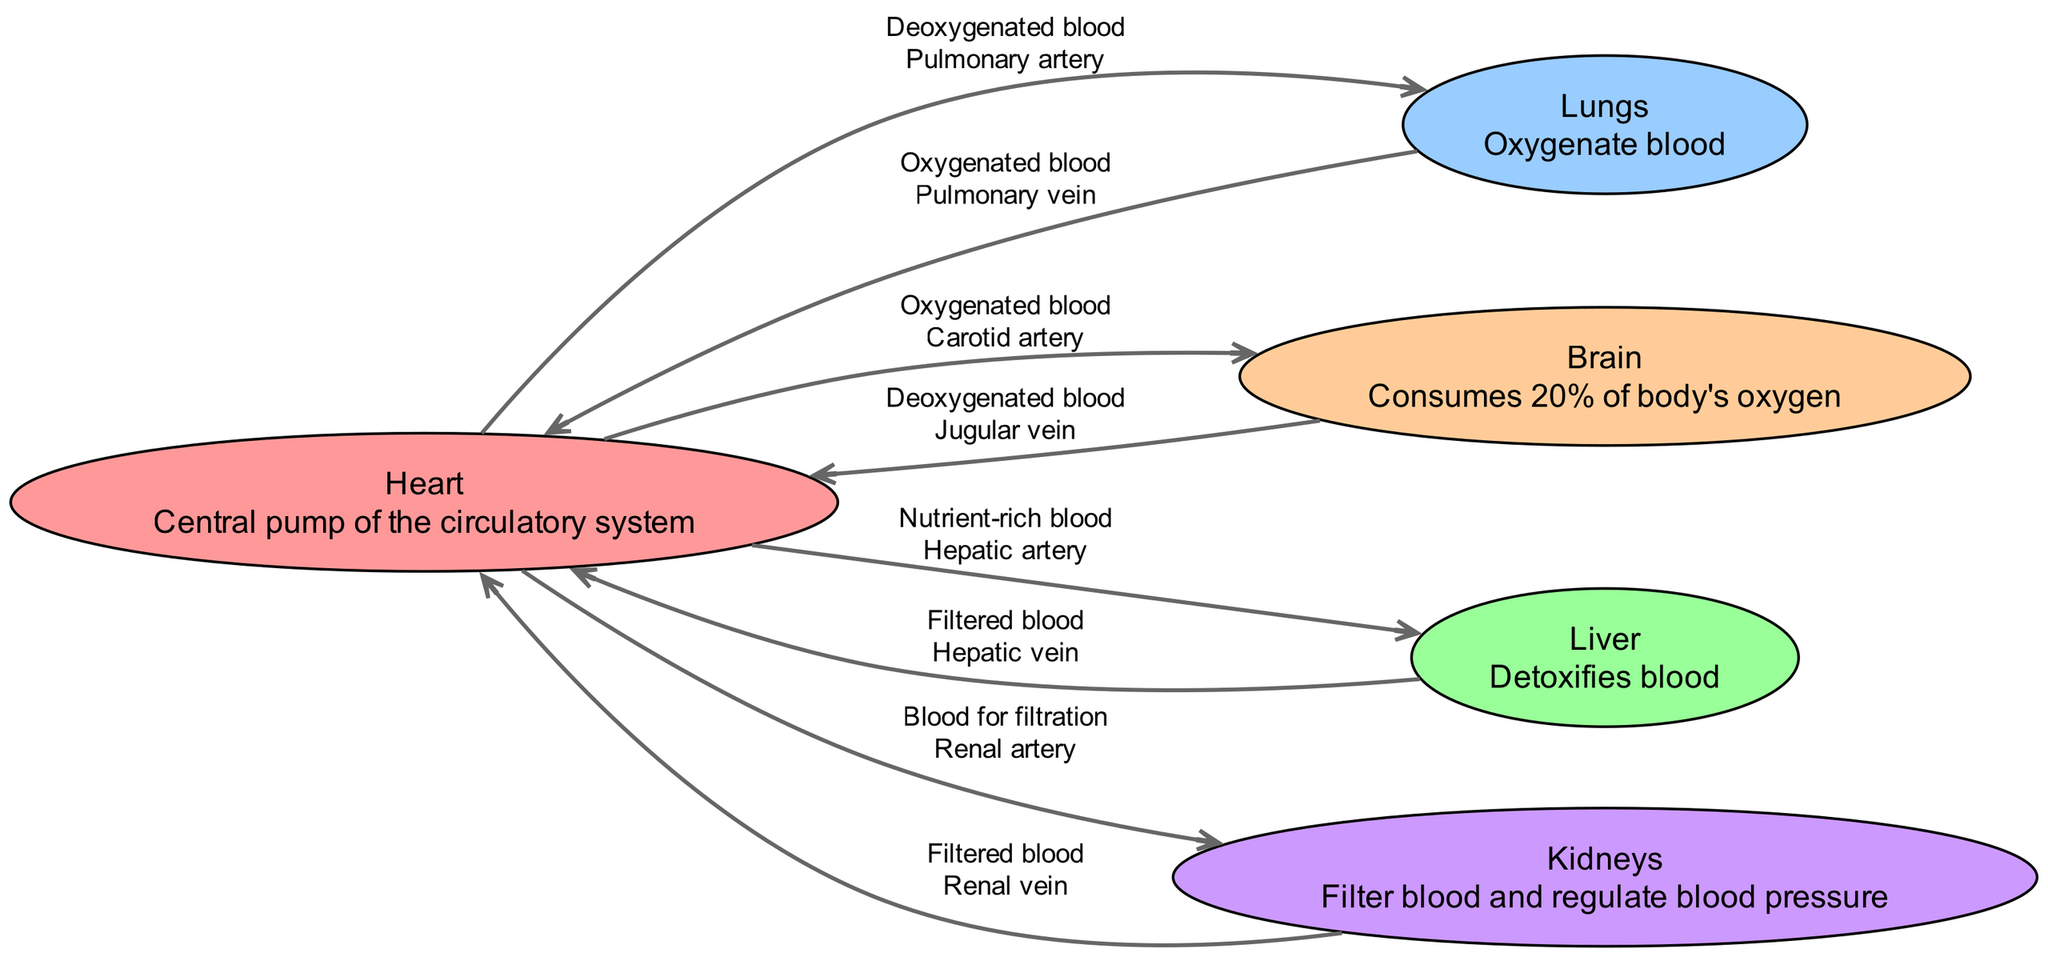What is the central pump of the circulatory system? The diagram identifies the "Heart" as the central pump, described in the node label. This is a basic descriptive question focusing on identifying a specific component of the circulatory system.
Answer: Heart How many nodes are in the diagram? By counting the entries in the "nodes" section of the data, we find there are 5 different organs indicated, all represented as nodes. This is a straightforward descriptive inquiry.
Answer: 5 What type of blood does the pulmonary artery carry? The edge connecting the heart to the lungs is labeled "Deoxygenated blood." This succinctly indicates the type of blood transported through this pathway.
Answer: Deoxygenated blood Which artery supplies blood to the brain? The diagram shows an edge leading from the heart to the brain labeled "Oxygenated blood," associated with the "Carotid artery." This connection illustrates the route oxygenated blood takes to the brain.
Answer: Carotid artery What organ receives filtered blood from the kidneys? Tracing the diagram from the kidneys to the heart shows the renal vein connecting them, demonstrating that the heart receives filtered blood after kidney processing. This question requires linking two processes within the diagram.
Answer: Heart What percentage of the body’s oxygen does the brain consume? The node description for the brain specifies that it consumes "20% of body's oxygen." This is a numerical inquiry based on the node's description.
Answer: 20% What is the role of the liver in the circulatory system? The liver is described in its node as having the function to "Detoxifies blood." This explanation captures the organ's role within the circulatory pathways as depicted in the diagram.
Answer: Detoxifies blood What type of blood is returned to the heart from the liver? The edge labeled "Filtered blood" connecting the liver to the heart, defined as being carried by the "Hepatic vein," indicates the nature of the blood flow returning to the heart from the liver.
Answer: Filtered blood Which vessels supply blood for filtration to the kidneys? The kidney's receiving blood from the heart is indicated by the edge labeled "Blood for filtration," which is connected via the "Renal artery." This demonstrates how blood flows into the kidneys specifically for filtering processes.
Answer: Renal artery 